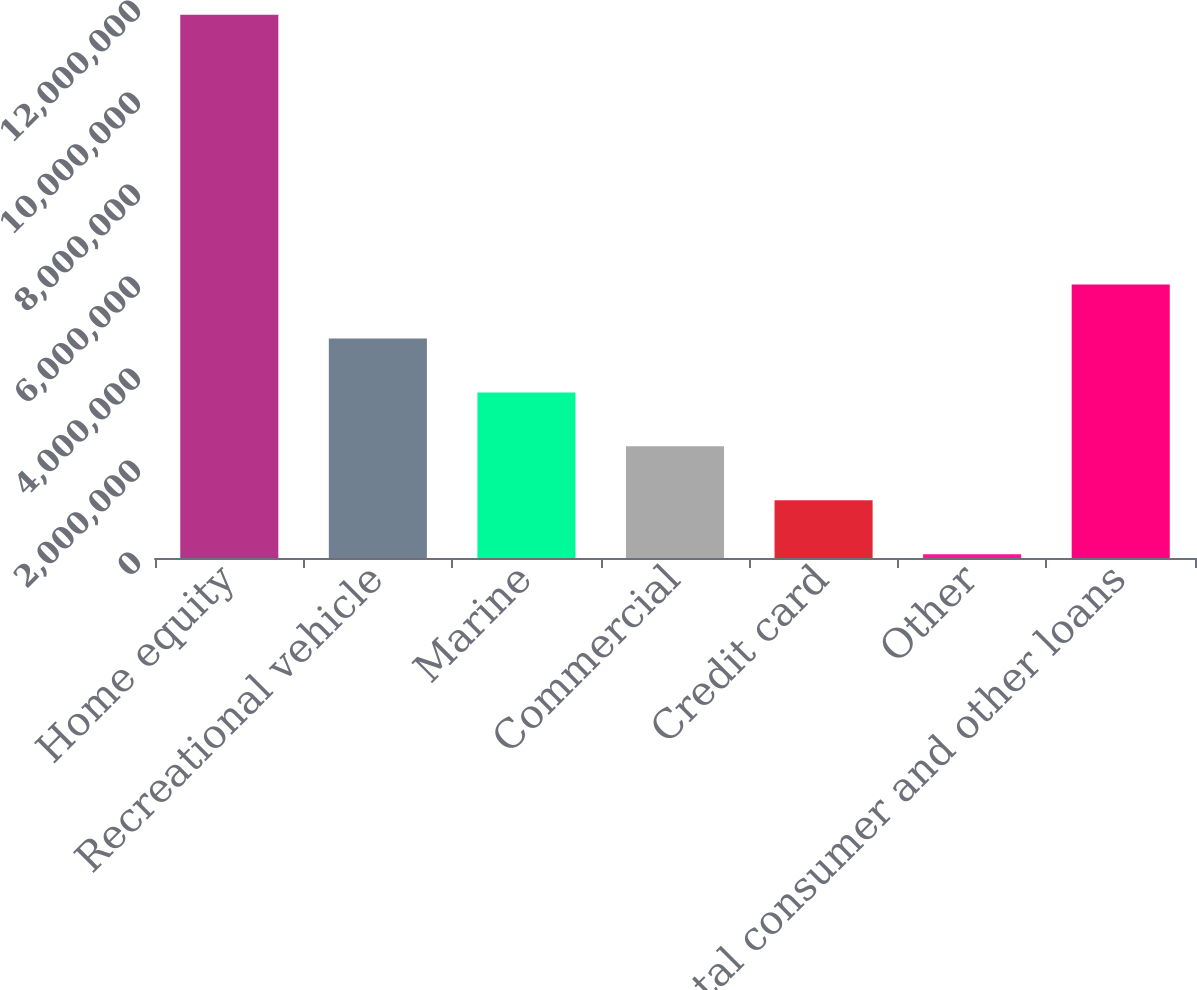Convert chart. <chart><loc_0><loc_0><loc_500><loc_500><bar_chart><fcel>Home equity<fcel>Recreational vehicle<fcel>Marine<fcel>Commercial<fcel>Credit card<fcel>Other<fcel>Total consumer and other loans<nl><fcel>1.18091e+07<fcel>4.77237e+06<fcel>3.59959e+06<fcel>2.4268e+06<fcel>1.25402e+06<fcel>81239<fcel>5.94515e+06<nl></chart> 